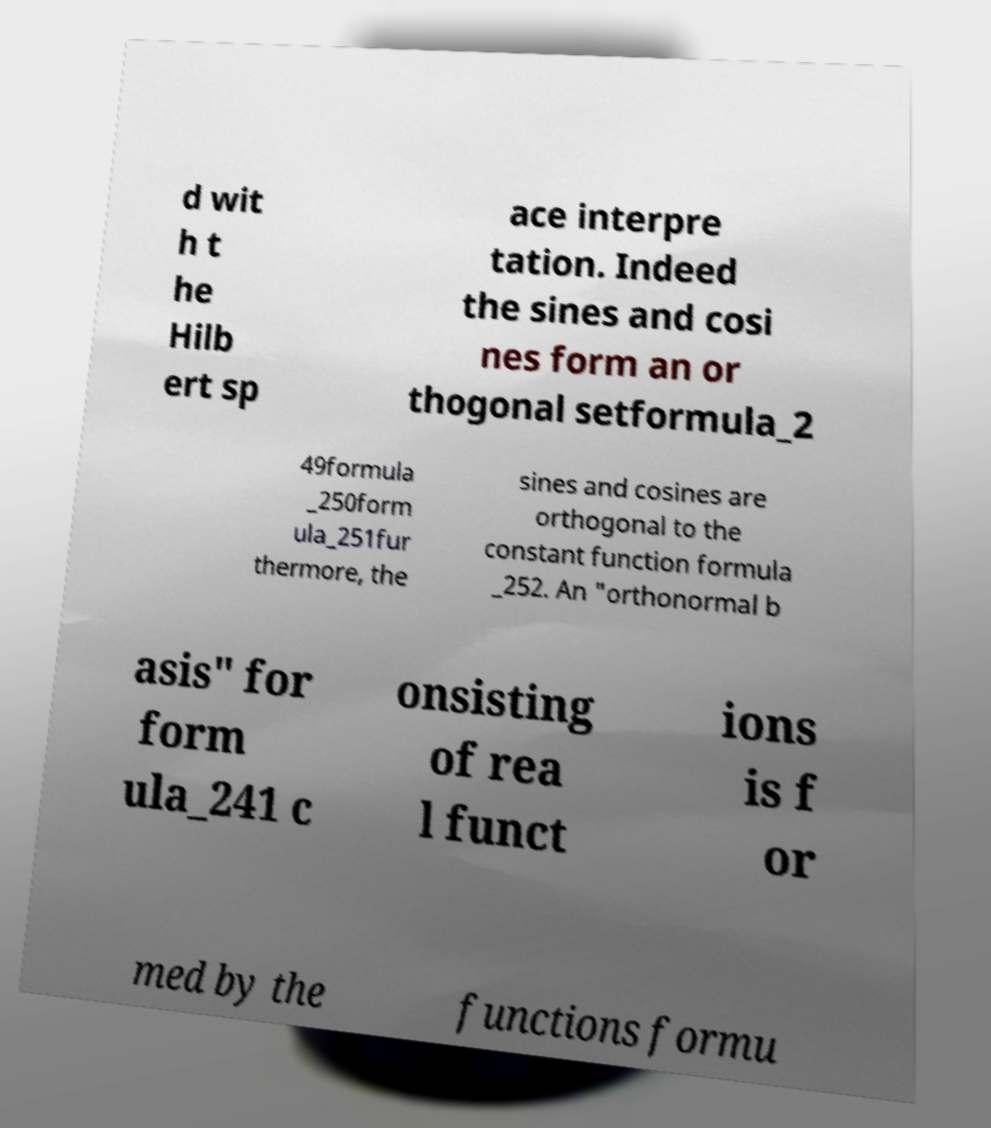I need the written content from this picture converted into text. Can you do that? d wit h t he Hilb ert sp ace interpre tation. Indeed the sines and cosi nes form an or thogonal setformula_2 49formula _250form ula_251fur thermore, the sines and cosines are orthogonal to the constant function formula _252. An "orthonormal b asis" for form ula_241 c onsisting of rea l funct ions is f or med by the functions formu 